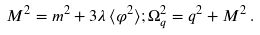<formula> <loc_0><loc_0><loc_500><loc_500>M ^ { 2 } = m ^ { 2 } + 3 \lambda \, \langle \varphi ^ { 2 } \rangle ; \Omega ^ { 2 } _ { q } = q ^ { 2 } + M ^ { 2 } \, .</formula> 